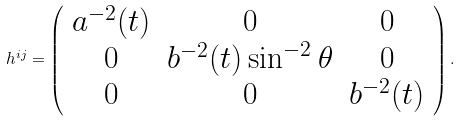Convert formula to latex. <formula><loc_0><loc_0><loc_500><loc_500>h ^ { i j } = \left ( \begin{array} { c c c } a ^ { - 2 } ( t ) & 0 & 0 \\ 0 & b ^ { - 2 } ( t ) \sin ^ { - 2 } \theta & 0 \\ 0 & 0 & b ^ { - 2 } ( t ) \end{array} \right ) .</formula> 